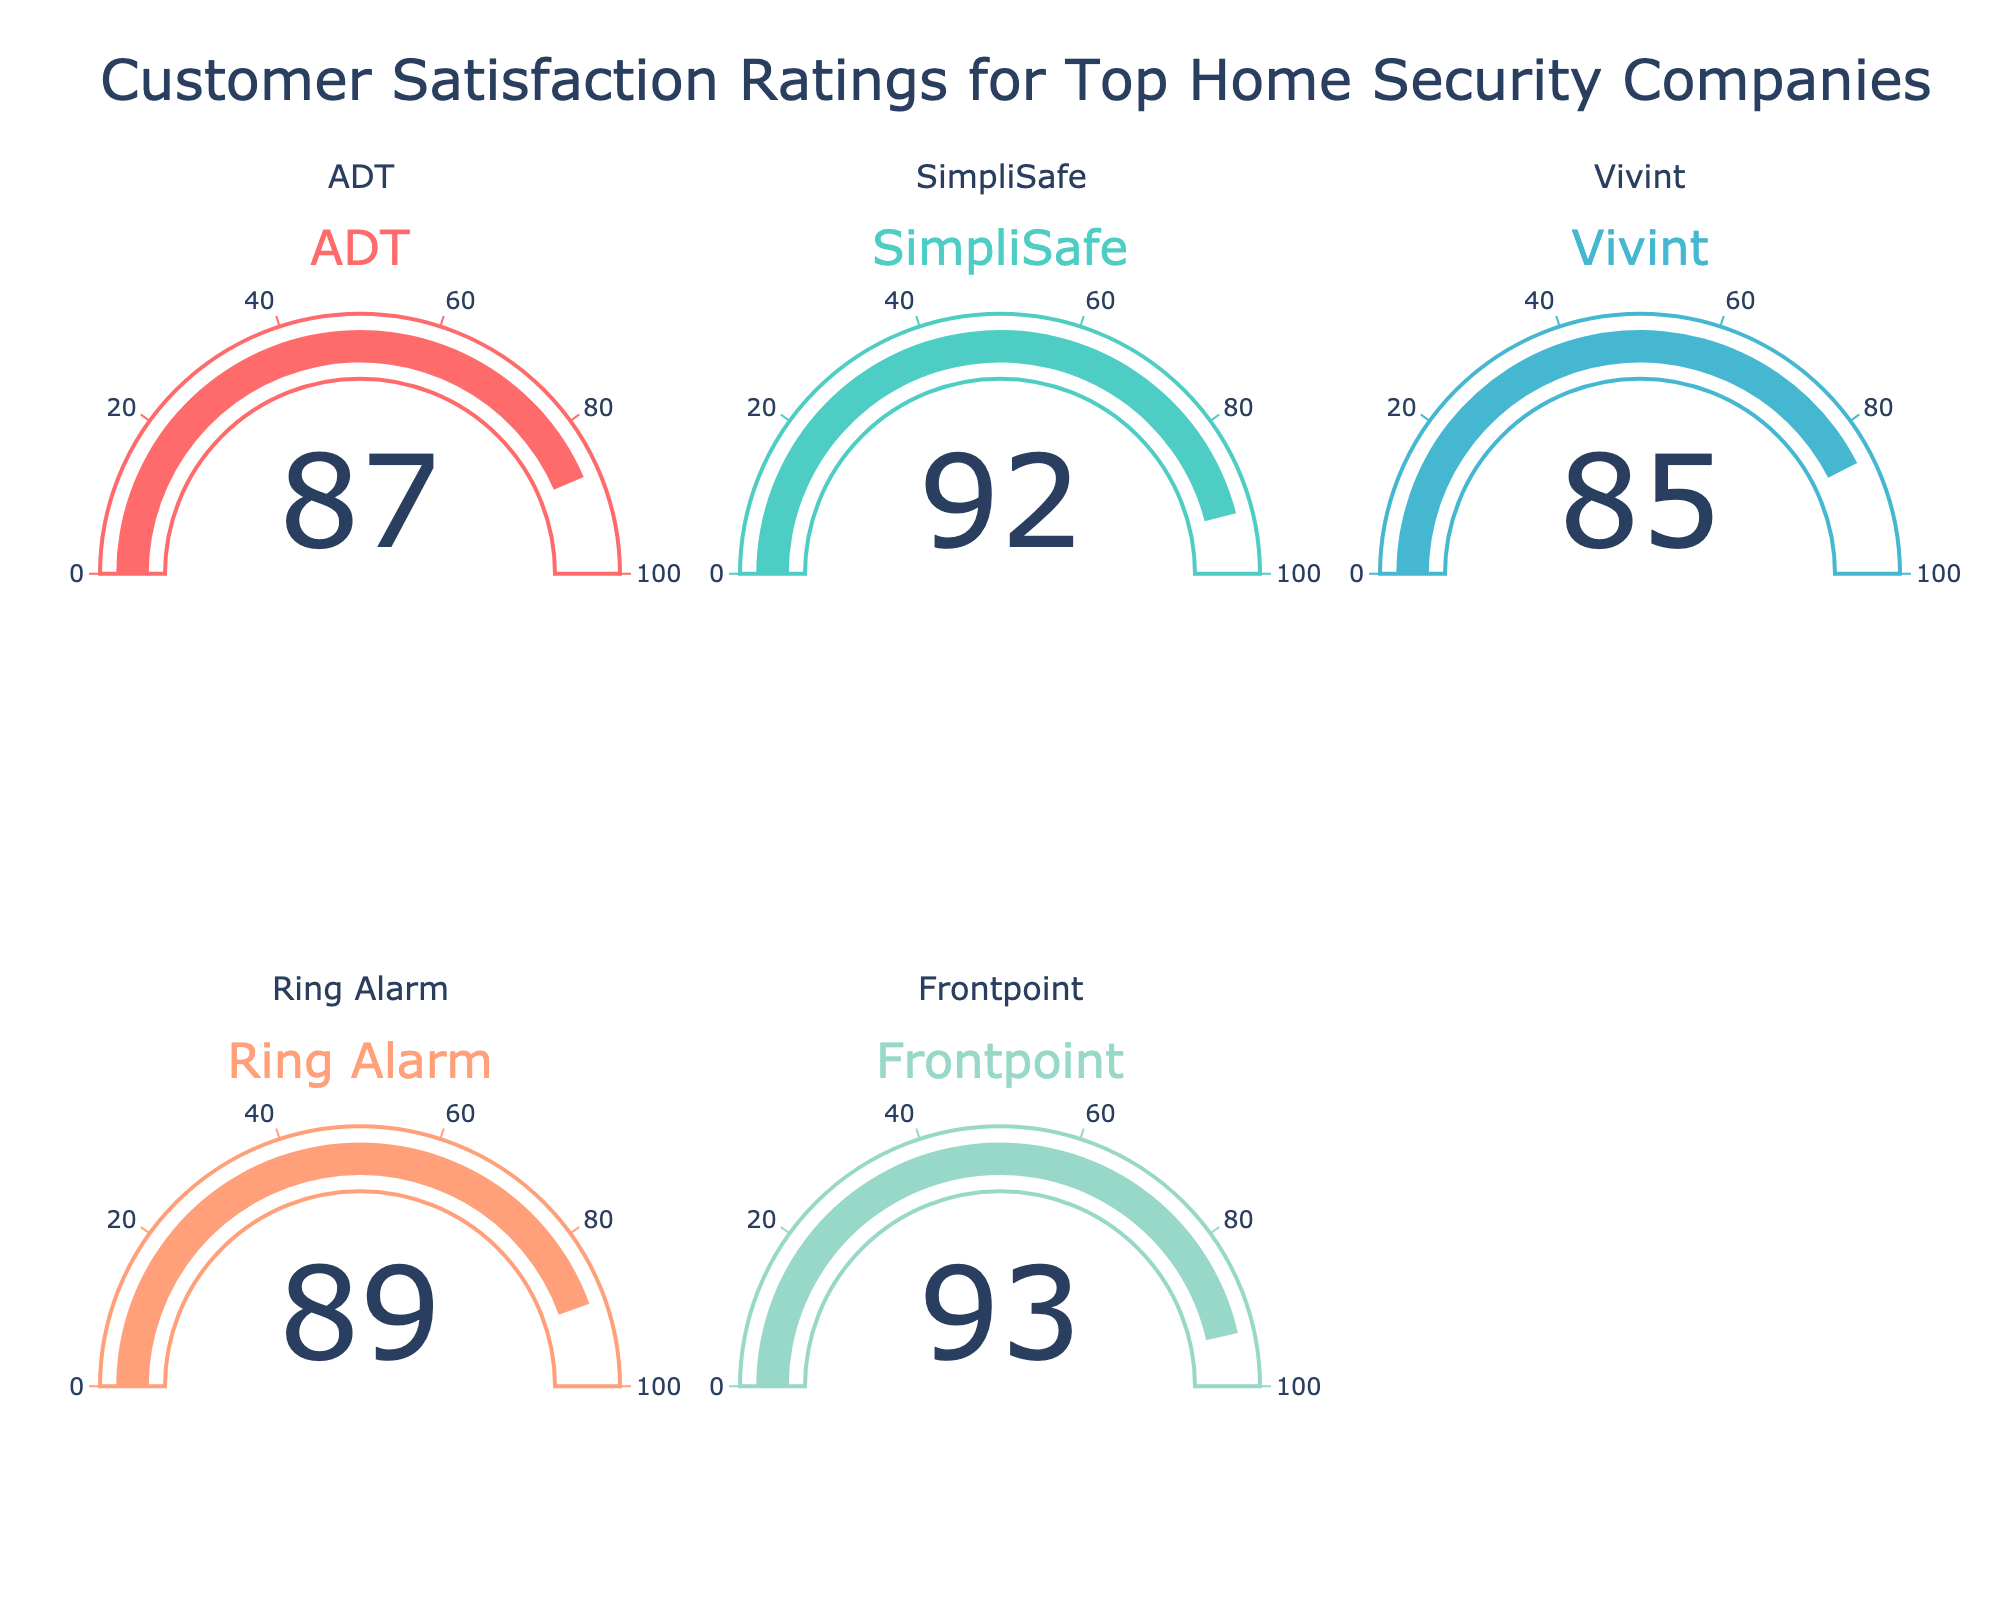Which company has the highest customer satisfaction rating? Frontpoint has the highest customer satisfaction rating shown on the gauge charts.
Answer: Frontpoint Which companies have a customer satisfaction rating above 90? By looking at the gauge charts, the companies with ratings above 90 are SimpliSafe and Frontpoint.
Answer: SimpliSafe and Frontpoint What is the difference in customer satisfaction rating between ADT and Vivint? The satisfaction rating for ADT is 87 and for Vivint is 85. The difference is 87 - 85 = 2.
Answer: 2 Which company has a lower satisfaction rating than Ring Alarm? Vivint has a lower satisfaction rating than Ring Alarm.
Answer: Vivint What is the average satisfaction rating of all the companies? Sum the satisfaction ratings: 87 (ADT) + 92 (SimpliSafe) + 85 (Vivint) + 89 (Ring Alarm) + 93 (Frontpoint) = 446. The average is 446 / 5 = 89.2.
Answer: 89.2 How many companies have a satisfaction rating of 85 or above? ADT, SimpliSafe, Vivint, Ring Alarm, and Frontpoint all have satisfaction ratings of 85 or above. Count these companies: 5.
Answer: 5 Which company has the closest satisfaction rating to Ring Alarm? Ring Alarm's rating is 89, and the closest rating is 87 by ADT.
Answer: ADT Are there any companies with the same customer satisfaction rating? Looking at the gauge figures, no companies have the same satisfaction rating.
Answer: No 